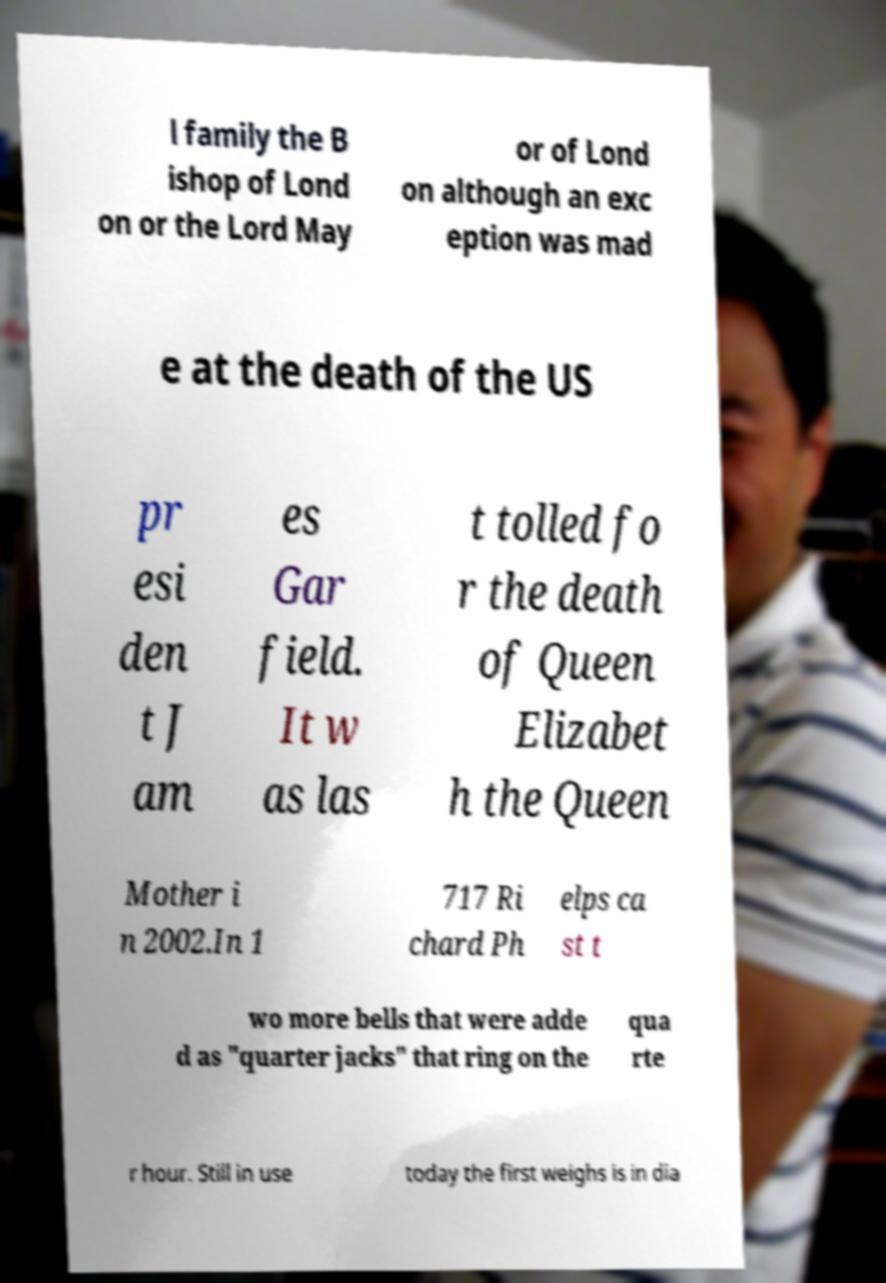What messages or text are displayed in this image? I need them in a readable, typed format. l family the B ishop of Lond on or the Lord May or of Lond on although an exc eption was mad e at the death of the US pr esi den t J am es Gar field. It w as las t tolled fo r the death of Queen Elizabet h the Queen Mother i n 2002.In 1 717 Ri chard Ph elps ca st t wo more bells that were adde d as "quarter jacks" that ring on the qua rte r hour. Still in use today the first weighs is in dia 